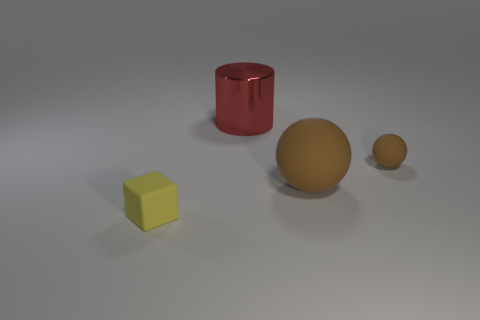How many brown balls must be subtracted to get 1 brown balls? 1 Add 2 tiny yellow rubber objects. How many objects exist? 6 Subtract all cylinders. How many objects are left? 3 Subtract all big red metal objects. Subtract all tiny brown spheres. How many objects are left? 2 Add 1 large brown objects. How many large brown objects are left? 2 Add 4 cyan rubber spheres. How many cyan rubber spheres exist? 4 Subtract 1 yellow cubes. How many objects are left? 3 